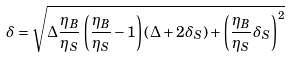<formula> <loc_0><loc_0><loc_500><loc_500>\delta = \sqrt { \Delta \frac { \eta _ { B } } { \eta _ { S } } \left ( \frac { \eta _ { B } } { \eta _ { S } } - 1 \right ) \left ( \Delta + 2 \delta _ { S } \right ) + \left ( \frac { \eta _ { B } } { \eta _ { S } } \delta _ { S } \right ) ^ { 2 } }</formula> 